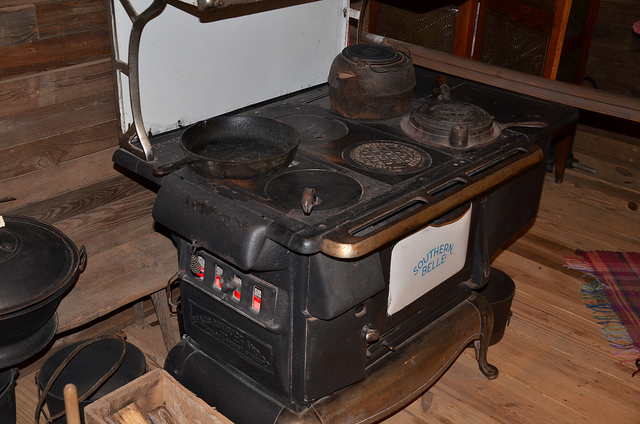Extract all visible text content from this image. SOUTHERN BELLE 